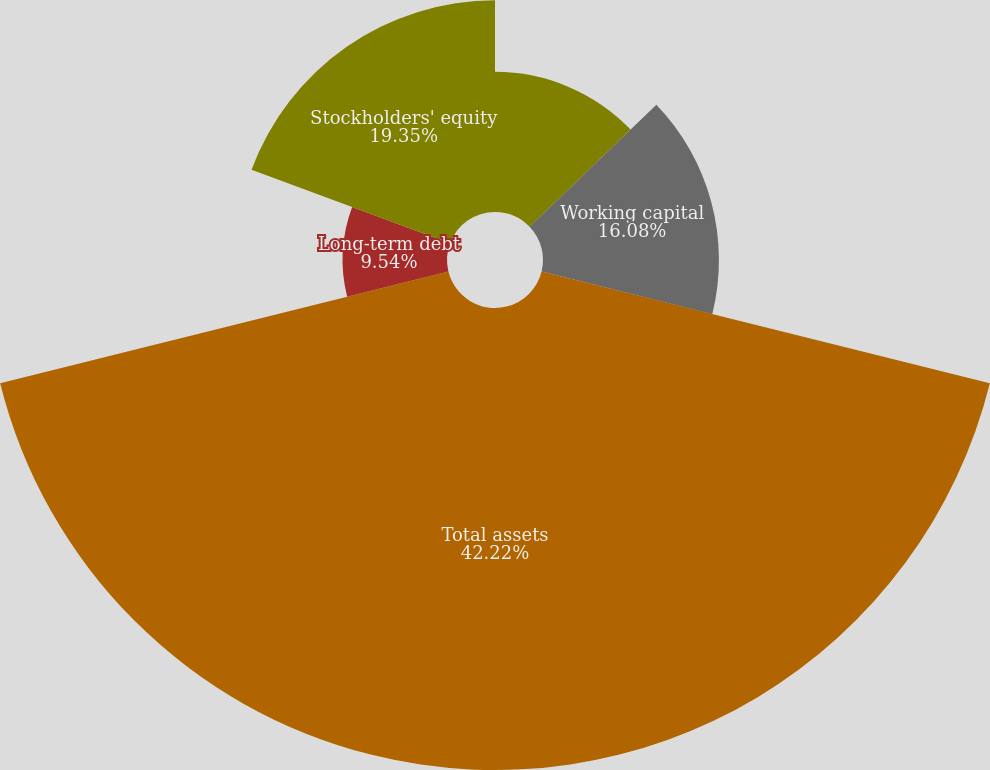Convert chart. <chart><loc_0><loc_0><loc_500><loc_500><pie_chart><fcel>Cash and cash equivalents and<fcel>Working capital<fcel>Total assets<fcel>Long-term debt<fcel>Stockholders' equity<nl><fcel>12.81%<fcel>16.08%<fcel>42.23%<fcel>9.54%<fcel>19.35%<nl></chart> 